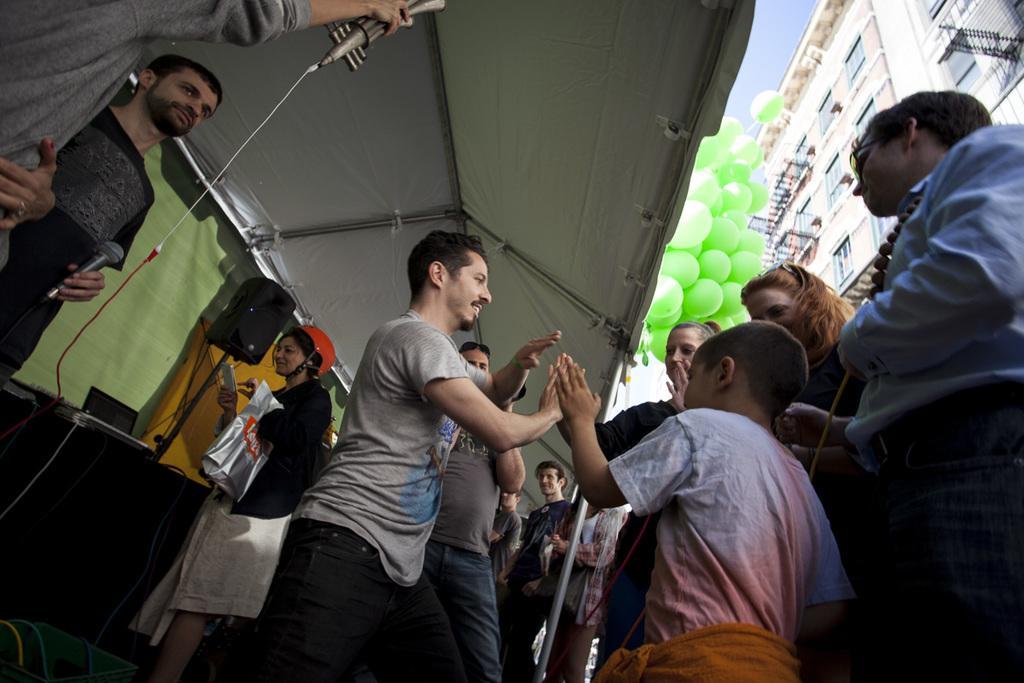Please provide a concise description of this image. In this picture there are some people standing. There were men and women in this picture. On the left side there are two members standing, holding mics in their hands. We can observe speakers which were in black color. There is a cream color curtain here. We can observe green color balloons and a building on the right side. In the background there is a sky. 